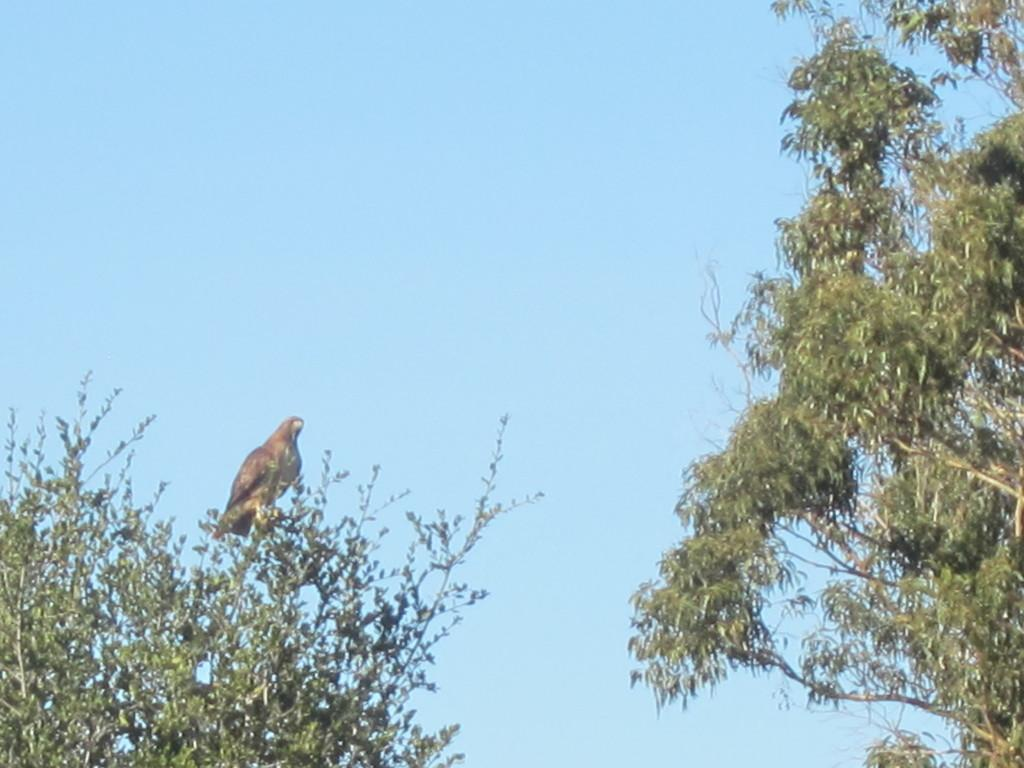What animal can be seen in the image? There is a bird on a tree in the image. What else can be seen in the image besides the bird? There are trees in the background of the image. What is visible in the background of the image? The sky is visible in the background of the image. What type of brass instrument is the giraffe playing in the image? There is no giraffe or brass instrument present in the image; it features a bird on a tree. Can you compare the bird's size to that of a giraffe in the image? There is no giraffe present in the image, so it is not possible to make a comparison. 